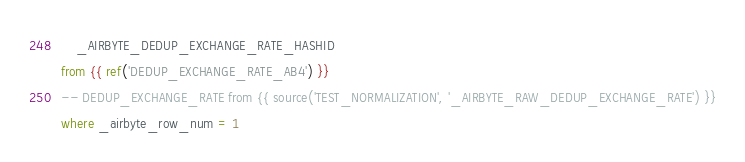Convert code to text. <code><loc_0><loc_0><loc_500><loc_500><_SQL_>    _AIRBYTE_DEDUP_EXCHANGE_RATE_HASHID
from {{ ref('DEDUP_EXCHANGE_RATE_AB4') }}
-- DEDUP_EXCHANGE_RATE from {{ source('TEST_NORMALIZATION', '_AIRBYTE_RAW_DEDUP_EXCHANGE_RATE') }}
where _airbyte_row_num = 1

</code> 